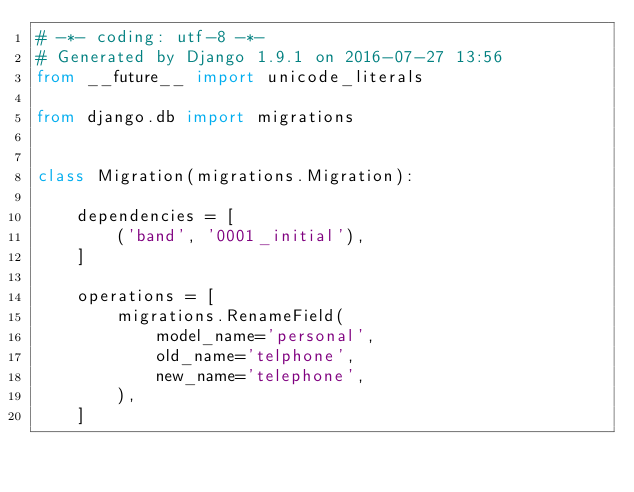Convert code to text. <code><loc_0><loc_0><loc_500><loc_500><_Python_># -*- coding: utf-8 -*-
# Generated by Django 1.9.1 on 2016-07-27 13:56
from __future__ import unicode_literals

from django.db import migrations


class Migration(migrations.Migration):

    dependencies = [
        ('band', '0001_initial'),
    ]

    operations = [
        migrations.RenameField(
            model_name='personal',
            old_name='telphone',
            new_name='telephone',
        ),
    ]
</code> 